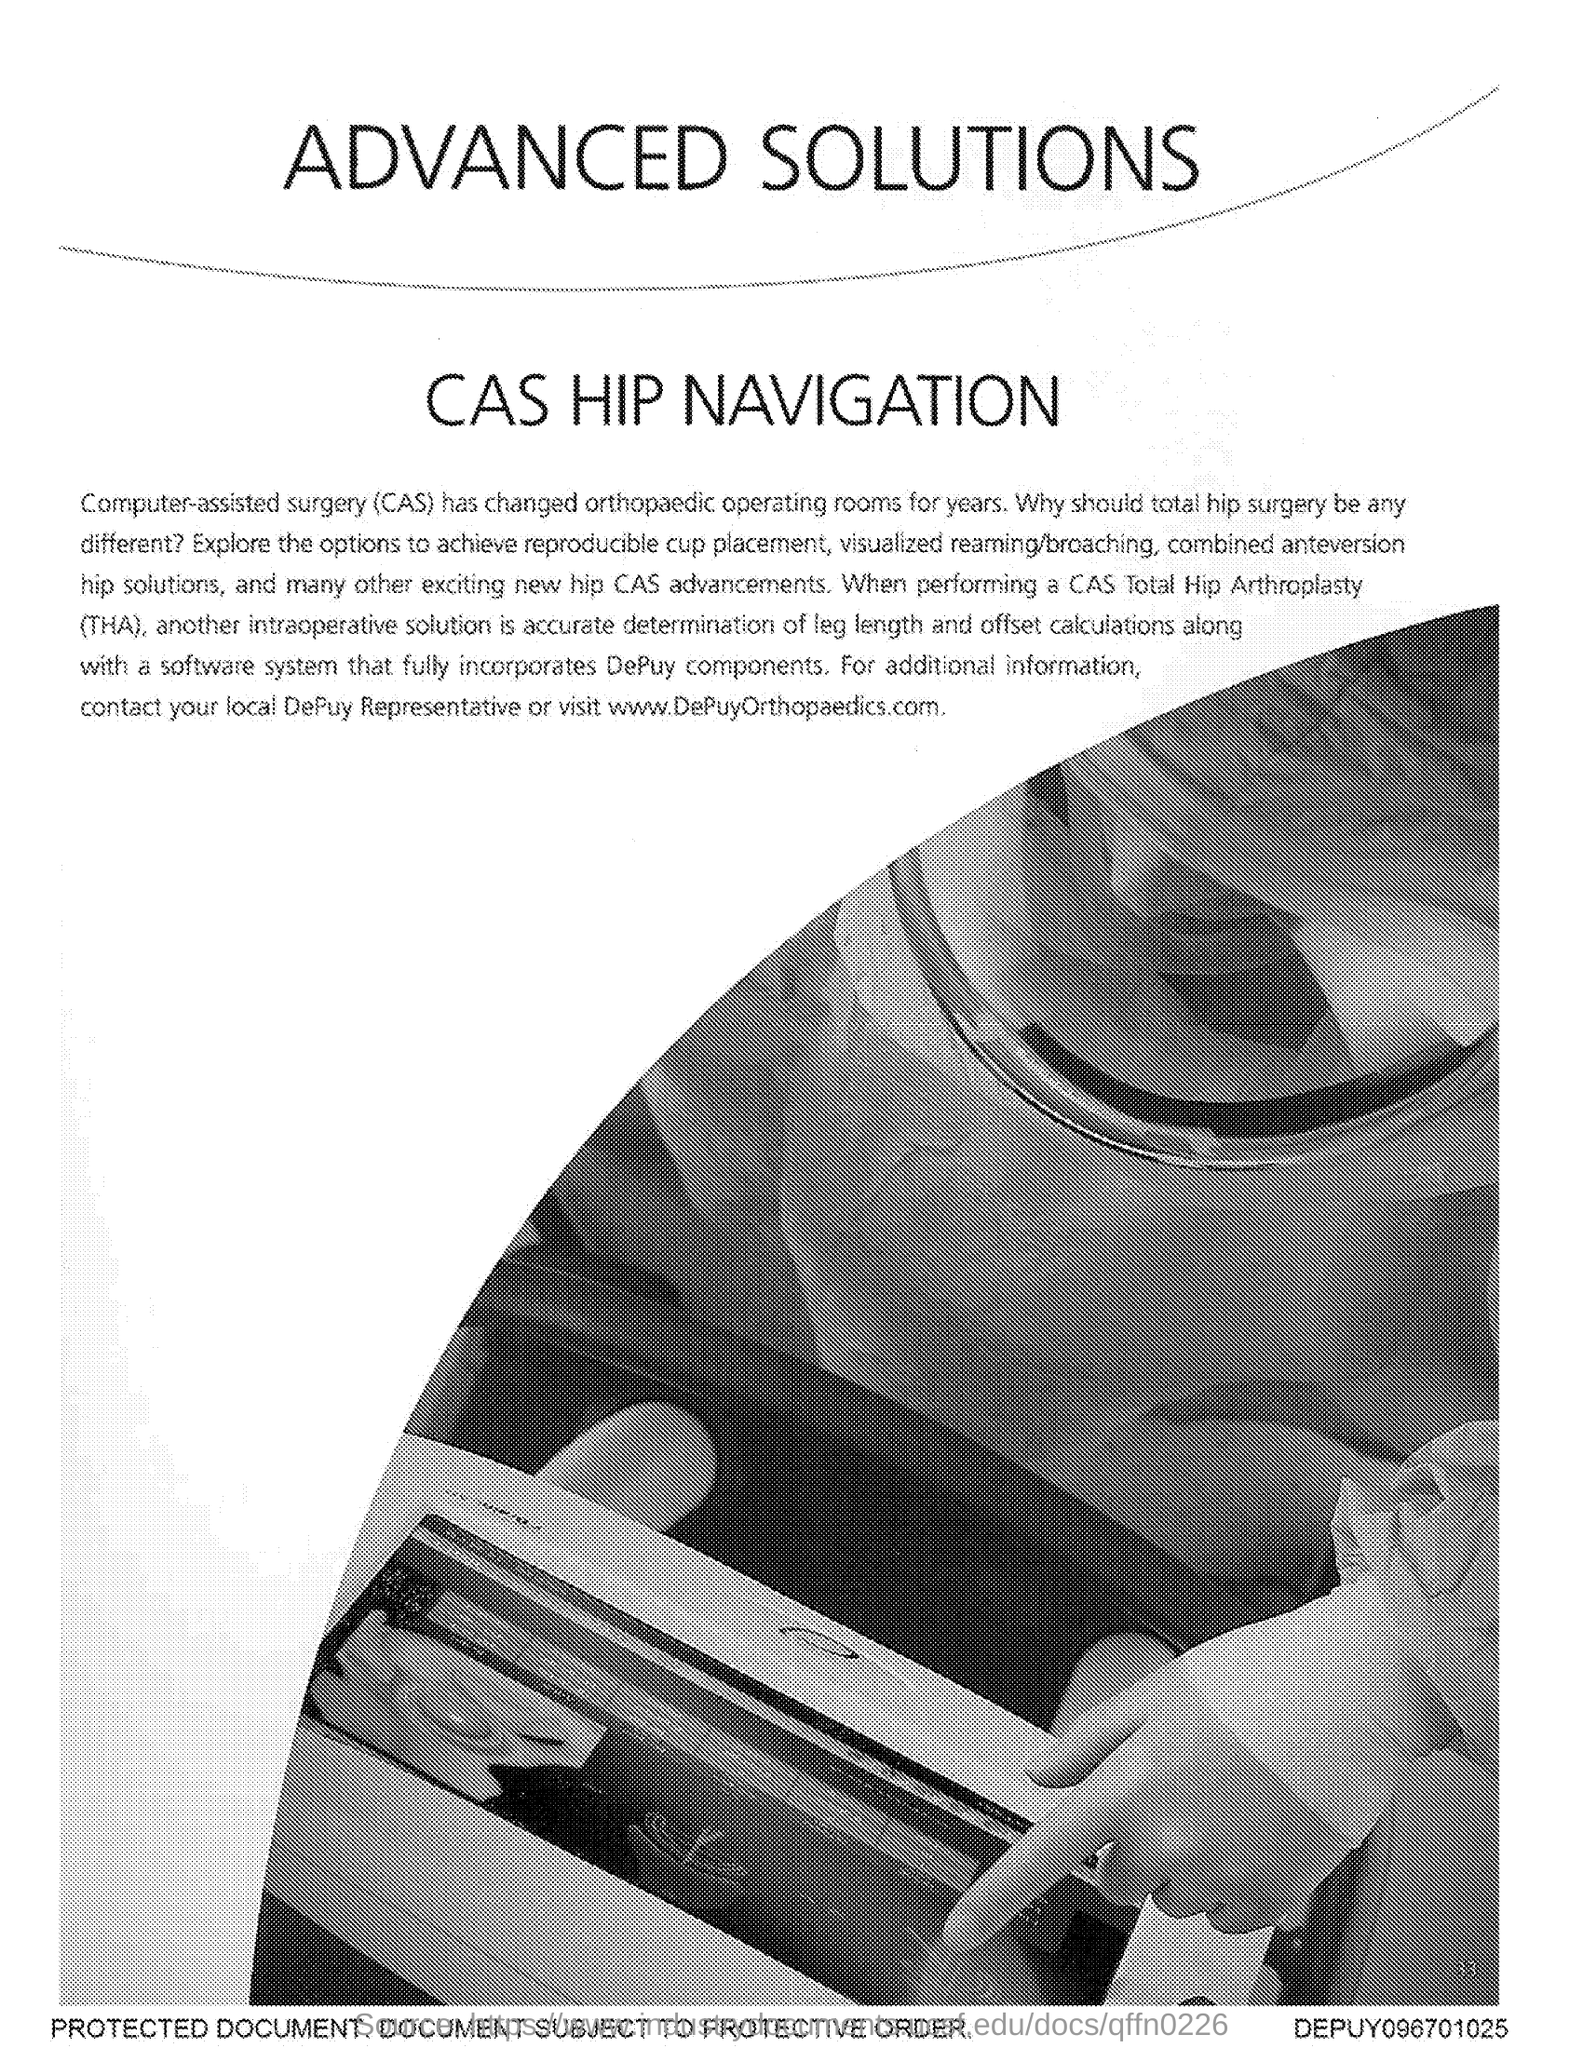What does cas stand for ?
Make the answer very short. Computer-assisted surgery. What does tha stand for ?
Offer a very short reply. Total hip arthroplasty. 